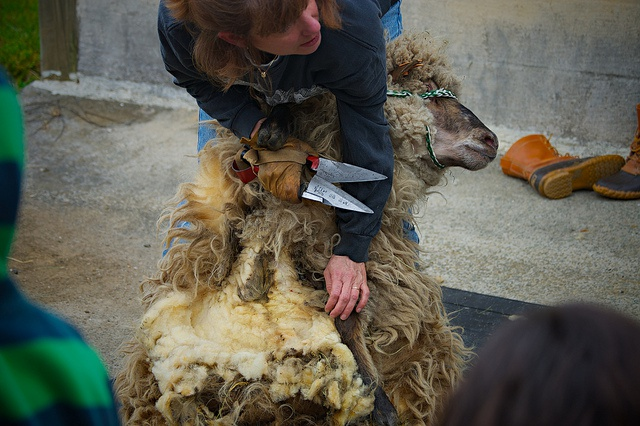Describe the objects in this image and their specific colors. I can see sheep in darkgreen, tan, gray, and black tones, people in darkgreen, black, maroon, gray, and navy tones, people in darkgreen, black, and gray tones, people in darkgreen, black, teal, and gray tones, and scissors in darkgreen, gray, and darkgray tones in this image. 